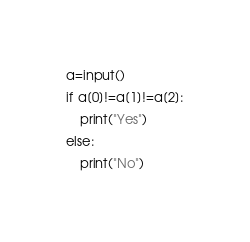<code> <loc_0><loc_0><loc_500><loc_500><_Python_>a=input()
if a[0]!=a[1]!=a[2]:
    print("Yes")
else:
    print("No")
</code> 